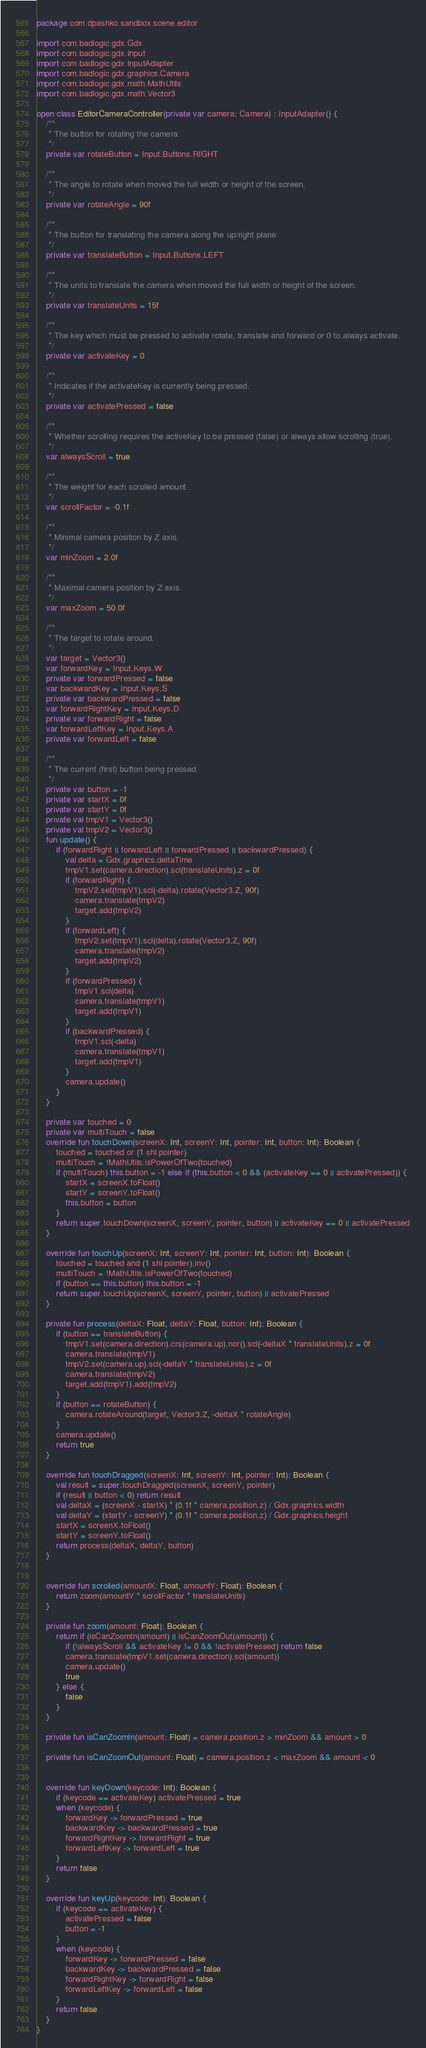<code> <loc_0><loc_0><loc_500><loc_500><_Kotlin_>package com.dpashko.sandbox.scene.editor

import com.badlogic.gdx.Gdx
import com.badlogic.gdx.Input
import com.badlogic.gdx.InputAdapter
import com.badlogic.gdx.graphics.Camera
import com.badlogic.gdx.math.MathUtils
import com.badlogic.gdx.math.Vector3

open class EditorCameraController(private var camera: Camera) : InputAdapter() {
    /**
     * The button for rotating the camera.
     */
    private var rotateButton = Input.Buttons.RIGHT

    /**
     * The angle to rotate when moved the full width or height of the screen.
     */
    private var rotateAngle = 90f

    /**
     * The button for translating the camera along the up/right plane
     */
    private var translateButton = Input.Buttons.LEFT

    /**
     * The units to translate the camera when moved the full width or height of the screen.
     */
    private var translateUnits = 15f

    /**
     * The key which must be pressed to activate rotate, translate and forward or 0 to always activate.
     */
    private var activateKey = 0

    /**
     * Indicates if the activateKey is currently being pressed.
     */
    private var activatePressed = false

    /**
     * Whether scrolling requires the activeKey to be pressed (false) or always allow scrolling (true).
     */
    var alwaysScroll = true

    /**
     * The weight for each scrolled amount.
     */
    var scrollFactor = -0.1f

    /**
     * Minimal camera position by Z axis.
     */
    var minZoom = 2.0f

    /**
     * Maximal camera position by Z axis.
     */
    var maxZoom = 50.0f

    /**
     * The target to rotate around.
     */
    var target = Vector3()
    var forwardKey = Input.Keys.W
    private var forwardPressed = false
    var backwardKey = Input.Keys.S
    private var backwardPressed = false
    var forwardRightKey = Input.Keys.D
    private var forwardRight = false
    var forwardLeftKey = Input.Keys.A
    private var forwardLeft = false

    /**
     * The current (first) button being pressed.
     */
    private var button = -1
    private var startX = 0f
    private var startY = 0f
    private val tmpV1 = Vector3()
    private val tmpV2 = Vector3()
    fun update() {
        if (forwardRight || forwardLeft || forwardPressed || backwardPressed) {
            val delta = Gdx.graphics.deltaTime
            tmpV1.set(camera.direction).scl(translateUnits).z = 0f
            if (forwardRight) {
                tmpV2.set(tmpV1).scl(-delta).rotate(Vector3.Z, 90f)
                camera.translate(tmpV2)
                target.add(tmpV2)
            }
            if (forwardLeft) {
                tmpV2.set(tmpV1).scl(delta).rotate(Vector3.Z, 90f)
                camera.translate(tmpV2)
                target.add(tmpV2)
            }
            if (forwardPressed) {
                tmpV1.scl(delta)
                camera.translate(tmpV1)
                target.add(tmpV1)
            }
            if (backwardPressed) {
                tmpV1.scl(-delta)
                camera.translate(tmpV1)
                target.add(tmpV1)
            }
            camera.update()
        }
    }

    private var touched = 0
    private var multiTouch = false
    override fun touchDown(screenX: Int, screenY: Int, pointer: Int, button: Int): Boolean {
        touched = touched or (1 shl pointer)
        multiTouch = !MathUtils.isPowerOfTwo(touched)
        if (multiTouch) this.button = -1 else if (this.button < 0 && (activateKey == 0 || activatePressed)) {
            startX = screenX.toFloat()
            startY = screenY.toFloat()
            this.button = button
        }
        return super.touchDown(screenX, screenY, pointer, button) || activateKey == 0 || activatePressed
    }

    override fun touchUp(screenX: Int, screenY: Int, pointer: Int, button: Int): Boolean {
        touched = touched and (1 shl pointer).inv()
        multiTouch = !MathUtils.isPowerOfTwo(touched)
        if (button == this.button) this.button = -1
        return super.touchUp(screenX, screenY, pointer, button) || activatePressed
    }

    private fun process(deltaX: Float, deltaY: Float, button: Int): Boolean {
        if (button == translateButton) {
            tmpV1.set(camera.direction).crs(camera.up).nor().scl(-deltaX * translateUnits).z = 0f
            camera.translate(tmpV1)
            tmpV2.set(camera.up).scl(-deltaY * translateUnits).z = 0f
            camera.translate(tmpV2)
            target.add(tmpV1).add(tmpV2)
        }
        if (button == rotateButton) {
            camera.rotateAround(target, Vector3.Z, -deltaX * rotateAngle)
        }
        camera.update()
        return true
    }

    override fun touchDragged(screenX: Int, screenY: Int, pointer: Int): Boolean {
        val result = super.touchDragged(screenX, screenY, pointer)
        if (result || button < 0) return result
        val deltaX = (screenX - startX) * (0.1f * camera.position.z) / Gdx.graphics.width
        val deltaY = (startY - screenY) * (0.1f * camera.position.z) / Gdx.graphics.height
        startX = screenX.toFloat()
        startY = screenY.toFloat()
        return process(deltaX, deltaY, button)
    }


    override fun scrolled(amountX: Float, amountY: Float): Boolean {
        return zoom(amountY * scrollFactor * translateUnits)
    }

    private fun zoom(amount: Float): Boolean {
        return if (isCanZoomIn(amount) || isCanZoomOut(amount)) {
            if (!alwaysScroll && activateKey != 0 && !activatePressed) return false
            camera.translate(tmpV1.set(camera.direction).scl(amount))
            camera.update()
            true
        } else {
            false
        }
    }

    private fun isCanZoomIn(amount: Float) = camera.position.z > minZoom && amount > 0

    private fun isCanZoomOut(amount: Float) = camera.position.z < maxZoom && amount < 0


    override fun keyDown(keycode: Int): Boolean {
        if (keycode == activateKey) activatePressed = true
        when (keycode) {
            forwardKey -> forwardPressed = true
            backwardKey -> backwardPressed = true
            forwardRightKey -> forwardRight = true
            forwardLeftKey -> forwardLeft = true
        }
        return false
    }

    override fun keyUp(keycode: Int): Boolean {
        if (keycode == activateKey) {
            activatePressed = false
            button = -1
        }
        when (keycode) {
            forwardKey -> forwardPressed = false
            backwardKey -> backwardPressed = false
            forwardRightKey -> forwardRight = false
            forwardLeftKey -> forwardLeft = false
        }
        return false
    }
}
</code> 